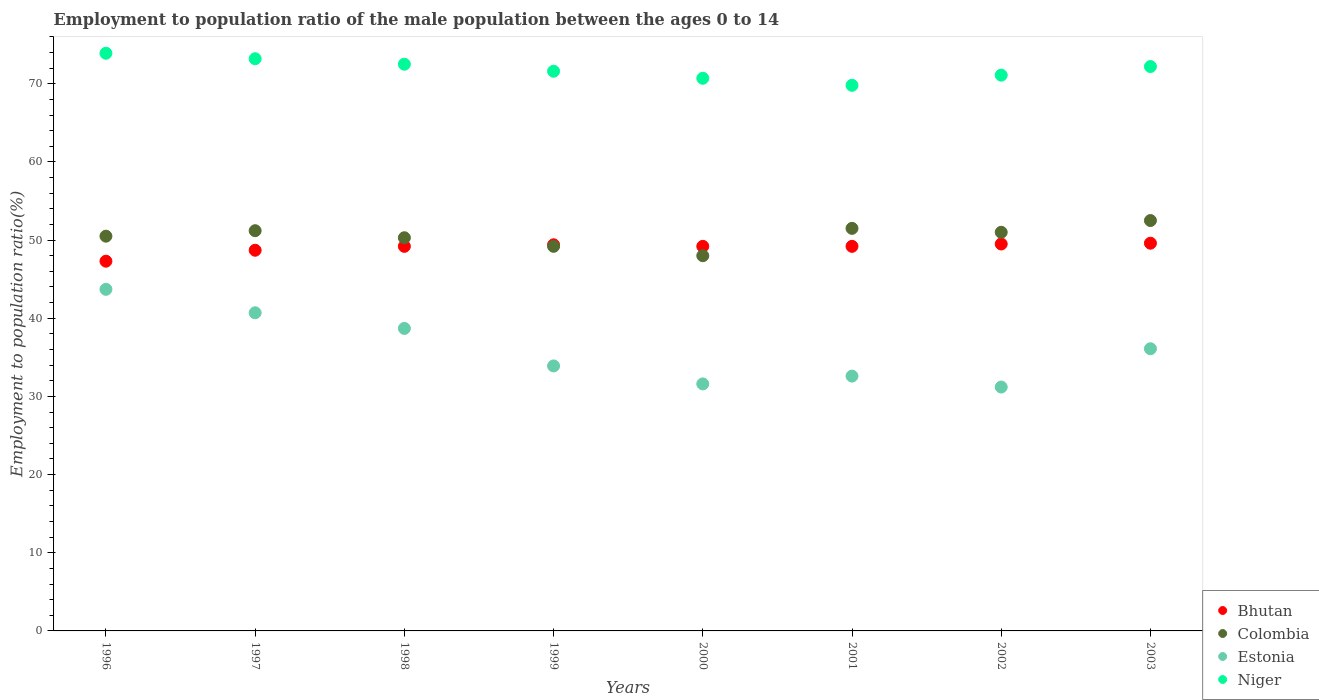Is the number of dotlines equal to the number of legend labels?
Make the answer very short. Yes. What is the employment to population ratio in Estonia in 2000?
Provide a short and direct response. 31.6. Across all years, what is the maximum employment to population ratio in Bhutan?
Provide a short and direct response. 49.6. Across all years, what is the minimum employment to population ratio in Bhutan?
Offer a terse response. 47.3. In which year was the employment to population ratio in Estonia maximum?
Provide a short and direct response. 1996. What is the total employment to population ratio in Niger in the graph?
Make the answer very short. 575. What is the difference between the employment to population ratio in Estonia in 1998 and that in 2000?
Your answer should be compact. 7.1. What is the difference between the employment to population ratio in Colombia in 2002 and the employment to population ratio in Estonia in 2000?
Your response must be concise. 19.4. What is the average employment to population ratio in Colombia per year?
Your answer should be very brief. 50.53. In the year 1996, what is the difference between the employment to population ratio in Colombia and employment to population ratio in Estonia?
Give a very brief answer. 6.8. What is the ratio of the employment to population ratio in Estonia in 1998 to that in 2001?
Give a very brief answer. 1.19. Is the difference between the employment to population ratio in Colombia in 1996 and 1999 greater than the difference between the employment to population ratio in Estonia in 1996 and 1999?
Your answer should be very brief. No. What is the difference between the highest and the second highest employment to population ratio in Bhutan?
Your answer should be very brief. 0.1. In how many years, is the employment to population ratio in Estonia greater than the average employment to population ratio in Estonia taken over all years?
Provide a short and direct response. 4. Does the employment to population ratio in Bhutan monotonically increase over the years?
Provide a succinct answer. No. Is the employment to population ratio in Niger strictly greater than the employment to population ratio in Bhutan over the years?
Offer a very short reply. Yes. Is the employment to population ratio in Niger strictly less than the employment to population ratio in Bhutan over the years?
Ensure brevity in your answer.  No. How many years are there in the graph?
Your answer should be compact. 8. Does the graph contain any zero values?
Your response must be concise. No. How many legend labels are there?
Ensure brevity in your answer.  4. How are the legend labels stacked?
Your answer should be very brief. Vertical. What is the title of the graph?
Offer a terse response. Employment to population ratio of the male population between the ages 0 to 14. What is the label or title of the X-axis?
Keep it short and to the point. Years. What is the Employment to population ratio(%) in Bhutan in 1996?
Offer a terse response. 47.3. What is the Employment to population ratio(%) in Colombia in 1996?
Your response must be concise. 50.5. What is the Employment to population ratio(%) of Estonia in 1996?
Give a very brief answer. 43.7. What is the Employment to population ratio(%) of Niger in 1996?
Make the answer very short. 73.9. What is the Employment to population ratio(%) in Bhutan in 1997?
Your answer should be very brief. 48.7. What is the Employment to population ratio(%) of Colombia in 1997?
Your answer should be compact. 51.2. What is the Employment to population ratio(%) of Estonia in 1997?
Give a very brief answer. 40.7. What is the Employment to population ratio(%) in Niger in 1997?
Your response must be concise. 73.2. What is the Employment to population ratio(%) of Bhutan in 1998?
Make the answer very short. 49.2. What is the Employment to population ratio(%) of Colombia in 1998?
Ensure brevity in your answer.  50.3. What is the Employment to population ratio(%) in Estonia in 1998?
Give a very brief answer. 38.7. What is the Employment to population ratio(%) in Niger in 1998?
Your answer should be very brief. 72.5. What is the Employment to population ratio(%) of Bhutan in 1999?
Keep it short and to the point. 49.4. What is the Employment to population ratio(%) of Colombia in 1999?
Your answer should be very brief. 49.2. What is the Employment to population ratio(%) in Estonia in 1999?
Offer a very short reply. 33.9. What is the Employment to population ratio(%) in Niger in 1999?
Make the answer very short. 71.6. What is the Employment to population ratio(%) of Bhutan in 2000?
Provide a succinct answer. 49.2. What is the Employment to population ratio(%) of Colombia in 2000?
Provide a succinct answer. 48. What is the Employment to population ratio(%) in Estonia in 2000?
Keep it short and to the point. 31.6. What is the Employment to population ratio(%) in Niger in 2000?
Make the answer very short. 70.7. What is the Employment to population ratio(%) of Bhutan in 2001?
Your response must be concise. 49.2. What is the Employment to population ratio(%) in Colombia in 2001?
Your answer should be compact. 51.5. What is the Employment to population ratio(%) of Estonia in 2001?
Your answer should be compact. 32.6. What is the Employment to population ratio(%) in Niger in 2001?
Offer a terse response. 69.8. What is the Employment to population ratio(%) in Bhutan in 2002?
Offer a terse response. 49.5. What is the Employment to population ratio(%) of Colombia in 2002?
Offer a terse response. 51. What is the Employment to population ratio(%) in Estonia in 2002?
Give a very brief answer. 31.2. What is the Employment to population ratio(%) of Niger in 2002?
Your answer should be very brief. 71.1. What is the Employment to population ratio(%) of Bhutan in 2003?
Your response must be concise. 49.6. What is the Employment to population ratio(%) of Colombia in 2003?
Give a very brief answer. 52.5. What is the Employment to population ratio(%) of Estonia in 2003?
Provide a succinct answer. 36.1. What is the Employment to population ratio(%) of Niger in 2003?
Offer a terse response. 72.2. Across all years, what is the maximum Employment to population ratio(%) in Bhutan?
Your response must be concise. 49.6. Across all years, what is the maximum Employment to population ratio(%) of Colombia?
Offer a terse response. 52.5. Across all years, what is the maximum Employment to population ratio(%) of Estonia?
Give a very brief answer. 43.7. Across all years, what is the maximum Employment to population ratio(%) in Niger?
Your response must be concise. 73.9. Across all years, what is the minimum Employment to population ratio(%) in Bhutan?
Provide a short and direct response. 47.3. Across all years, what is the minimum Employment to population ratio(%) in Colombia?
Offer a terse response. 48. Across all years, what is the minimum Employment to population ratio(%) in Estonia?
Give a very brief answer. 31.2. Across all years, what is the minimum Employment to population ratio(%) in Niger?
Provide a short and direct response. 69.8. What is the total Employment to population ratio(%) of Bhutan in the graph?
Offer a terse response. 392.1. What is the total Employment to population ratio(%) of Colombia in the graph?
Keep it short and to the point. 404.2. What is the total Employment to population ratio(%) of Estonia in the graph?
Offer a terse response. 288.5. What is the total Employment to population ratio(%) in Niger in the graph?
Your response must be concise. 575. What is the difference between the Employment to population ratio(%) in Bhutan in 1996 and that in 1997?
Your response must be concise. -1.4. What is the difference between the Employment to population ratio(%) in Bhutan in 1996 and that in 1998?
Keep it short and to the point. -1.9. What is the difference between the Employment to population ratio(%) of Colombia in 1996 and that in 1998?
Your answer should be compact. 0.2. What is the difference between the Employment to population ratio(%) of Estonia in 1996 and that in 1998?
Provide a succinct answer. 5. What is the difference between the Employment to population ratio(%) of Niger in 1996 and that in 1998?
Provide a short and direct response. 1.4. What is the difference between the Employment to population ratio(%) in Estonia in 1996 and that in 1999?
Your response must be concise. 9.8. What is the difference between the Employment to population ratio(%) in Bhutan in 1996 and that in 2000?
Provide a short and direct response. -1.9. What is the difference between the Employment to population ratio(%) in Colombia in 1996 and that in 2000?
Your answer should be very brief. 2.5. What is the difference between the Employment to population ratio(%) in Colombia in 1996 and that in 2001?
Offer a very short reply. -1. What is the difference between the Employment to population ratio(%) of Estonia in 1996 and that in 2001?
Ensure brevity in your answer.  11.1. What is the difference between the Employment to population ratio(%) in Colombia in 1996 and that in 2003?
Provide a short and direct response. -2. What is the difference between the Employment to population ratio(%) of Bhutan in 1997 and that in 1998?
Offer a very short reply. -0.5. What is the difference between the Employment to population ratio(%) of Colombia in 1997 and that in 1998?
Offer a terse response. 0.9. What is the difference between the Employment to population ratio(%) of Colombia in 1997 and that in 1999?
Keep it short and to the point. 2. What is the difference between the Employment to population ratio(%) in Colombia in 1997 and that in 2000?
Your response must be concise. 3.2. What is the difference between the Employment to population ratio(%) of Estonia in 1997 and that in 2000?
Ensure brevity in your answer.  9.1. What is the difference between the Employment to population ratio(%) in Niger in 1997 and that in 2000?
Provide a succinct answer. 2.5. What is the difference between the Employment to population ratio(%) in Colombia in 1997 and that in 2001?
Ensure brevity in your answer.  -0.3. What is the difference between the Employment to population ratio(%) of Estonia in 1997 and that in 2001?
Your answer should be compact. 8.1. What is the difference between the Employment to population ratio(%) in Niger in 1997 and that in 2001?
Offer a terse response. 3.4. What is the difference between the Employment to population ratio(%) in Estonia in 1997 and that in 2002?
Provide a short and direct response. 9.5. What is the difference between the Employment to population ratio(%) of Estonia in 1997 and that in 2003?
Your answer should be very brief. 4.6. What is the difference between the Employment to population ratio(%) of Niger in 1997 and that in 2003?
Your response must be concise. 1. What is the difference between the Employment to population ratio(%) in Colombia in 1998 and that in 1999?
Keep it short and to the point. 1.1. What is the difference between the Employment to population ratio(%) in Estonia in 1998 and that in 2000?
Provide a short and direct response. 7.1. What is the difference between the Employment to population ratio(%) of Estonia in 1998 and that in 2001?
Give a very brief answer. 6.1. What is the difference between the Employment to population ratio(%) of Colombia in 1998 and that in 2002?
Ensure brevity in your answer.  -0.7. What is the difference between the Employment to population ratio(%) in Estonia in 1998 and that in 2002?
Give a very brief answer. 7.5. What is the difference between the Employment to population ratio(%) of Niger in 1998 and that in 2002?
Your answer should be very brief. 1.4. What is the difference between the Employment to population ratio(%) in Bhutan in 1998 and that in 2003?
Keep it short and to the point. -0.4. What is the difference between the Employment to population ratio(%) of Estonia in 1998 and that in 2003?
Your response must be concise. 2.6. What is the difference between the Employment to population ratio(%) in Niger in 1998 and that in 2003?
Give a very brief answer. 0.3. What is the difference between the Employment to population ratio(%) of Colombia in 1999 and that in 2000?
Offer a very short reply. 1.2. What is the difference between the Employment to population ratio(%) of Estonia in 1999 and that in 2000?
Give a very brief answer. 2.3. What is the difference between the Employment to population ratio(%) of Colombia in 1999 and that in 2001?
Provide a short and direct response. -2.3. What is the difference between the Employment to population ratio(%) of Colombia in 1999 and that in 2002?
Your response must be concise. -1.8. What is the difference between the Employment to population ratio(%) in Estonia in 1999 and that in 2002?
Give a very brief answer. 2.7. What is the difference between the Employment to population ratio(%) in Niger in 1999 and that in 2002?
Offer a very short reply. 0.5. What is the difference between the Employment to population ratio(%) in Colombia in 2000 and that in 2001?
Your answer should be very brief. -3.5. What is the difference between the Employment to population ratio(%) of Bhutan in 2000 and that in 2002?
Ensure brevity in your answer.  -0.3. What is the difference between the Employment to population ratio(%) of Niger in 2000 and that in 2002?
Provide a short and direct response. -0.4. What is the difference between the Employment to population ratio(%) of Bhutan in 2000 and that in 2003?
Provide a short and direct response. -0.4. What is the difference between the Employment to population ratio(%) in Estonia in 2000 and that in 2003?
Your response must be concise. -4.5. What is the difference between the Employment to population ratio(%) in Estonia in 2001 and that in 2002?
Your response must be concise. 1.4. What is the difference between the Employment to population ratio(%) of Niger in 2001 and that in 2002?
Your response must be concise. -1.3. What is the difference between the Employment to population ratio(%) in Colombia in 2001 and that in 2003?
Offer a very short reply. -1. What is the difference between the Employment to population ratio(%) in Niger in 2001 and that in 2003?
Ensure brevity in your answer.  -2.4. What is the difference between the Employment to population ratio(%) of Bhutan in 2002 and that in 2003?
Your answer should be very brief. -0.1. What is the difference between the Employment to population ratio(%) of Estonia in 2002 and that in 2003?
Keep it short and to the point. -4.9. What is the difference between the Employment to population ratio(%) of Bhutan in 1996 and the Employment to population ratio(%) of Niger in 1997?
Provide a short and direct response. -25.9. What is the difference between the Employment to population ratio(%) in Colombia in 1996 and the Employment to population ratio(%) in Estonia in 1997?
Ensure brevity in your answer.  9.8. What is the difference between the Employment to population ratio(%) of Colombia in 1996 and the Employment to population ratio(%) of Niger in 1997?
Your response must be concise. -22.7. What is the difference between the Employment to population ratio(%) in Estonia in 1996 and the Employment to population ratio(%) in Niger in 1997?
Provide a short and direct response. -29.5. What is the difference between the Employment to population ratio(%) in Bhutan in 1996 and the Employment to population ratio(%) in Colombia in 1998?
Give a very brief answer. -3. What is the difference between the Employment to population ratio(%) of Bhutan in 1996 and the Employment to population ratio(%) of Niger in 1998?
Keep it short and to the point. -25.2. What is the difference between the Employment to population ratio(%) in Estonia in 1996 and the Employment to population ratio(%) in Niger in 1998?
Your response must be concise. -28.8. What is the difference between the Employment to population ratio(%) in Bhutan in 1996 and the Employment to population ratio(%) in Colombia in 1999?
Give a very brief answer. -1.9. What is the difference between the Employment to population ratio(%) of Bhutan in 1996 and the Employment to population ratio(%) of Niger in 1999?
Make the answer very short. -24.3. What is the difference between the Employment to population ratio(%) of Colombia in 1996 and the Employment to population ratio(%) of Estonia in 1999?
Your answer should be compact. 16.6. What is the difference between the Employment to population ratio(%) in Colombia in 1996 and the Employment to population ratio(%) in Niger in 1999?
Give a very brief answer. -21.1. What is the difference between the Employment to population ratio(%) of Estonia in 1996 and the Employment to population ratio(%) of Niger in 1999?
Offer a terse response. -27.9. What is the difference between the Employment to population ratio(%) of Bhutan in 1996 and the Employment to population ratio(%) of Colombia in 2000?
Make the answer very short. -0.7. What is the difference between the Employment to population ratio(%) in Bhutan in 1996 and the Employment to population ratio(%) in Niger in 2000?
Provide a short and direct response. -23.4. What is the difference between the Employment to population ratio(%) of Colombia in 1996 and the Employment to population ratio(%) of Niger in 2000?
Offer a very short reply. -20.2. What is the difference between the Employment to population ratio(%) of Estonia in 1996 and the Employment to population ratio(%) of Niger in 2000?
Offer a terse response. -27. What is the difference between the Employment to population ratio(%) of Bhutan in 1996 and the Employment to population ratio(%) of Colombia in 2001?
Provide a succinct answer. -4.2. What is the difference between the Employment to population ratio(%) in Bhutan in 1996 and the Employment to population ratio(%) in Estonia in 2001?
Offer a terse response. 14.7. What is the difference between the Employment to population ratio(%) in Bhutan in 1996 and the Employment to population ratio(%) in Niger in 2001?
Provide a short and direct response. -22.5. What is the difference between the Employment to population ratio(%) of Colombia in 1996 and the Employment to population ratio(%) of Niger in 2001?
Offer a terse response. -19.3. What is the difference between the Employment to population ratio(%) of Estonia in 1996 and the Employment to population ratio(%) of Niger in 2001?
Offer a terse response. -26.1. What is the difference between the Employment to population ratio(%) in Bhutan in 1996 and the Employment to population ratio(%) in Estonia in 2002?
Offer a terse response. 16.1. What is the difference between the Employment to population ratio(%) of Bhutan in 1996 and the Employment to population ratio(%) of Niger in 2002?
Your answer should be compact. -23.8. What is the difference between the Employment to population ratio(%) in Colombia in 1996 and the Employment to population ratio(%) in Estonia in 2002?
Your answer should be very brief. 19.3. What is the difference between the Employment to population ratio(%) in Colombia in 1996 and the Employment to population ratio(%) in Niger in 2002?
Provide a succinct answer. -20.6. What is the difference between the Employment to population ratio(%) of Estonia in 1996 and the Employment to population ratio(%) of Niger in 2002?
Make the answer very short. -27.4. What is the difference between the Employment to population ratio(%) of Bhutan in 1996 and the Employment to population ratio(%) of Colombia in 2003?
Your answer should be very brief. -5.2. What is the difference between the Employment to population ratio(%) in Bhutan in 1996 and the Employment to population ratio(%) in Estonia in 2003?
Your answer should be compact. 11.2. What is the difference between the Employment to population ratio(%) of Bhutan in 1996 and the Employment to population ratio(%) of Niger in 2003?
Your answer should be compact. -24.9. What is the difference between the Employment to population ratio(%) of Colombia in 1996 and the Employment to population ratio(%) of Estonia in 2003?
Your answer should be compact. 14.4. What is the difference between the Employment to population ratio(%) in Colombia in 1996 and the Employment to population ratio(%) in Niger in 2003?
Provide a succinct answer. -21.7. What is the difference between the Employment to population ratio(%) of Estonia in 1996 and the Employment to population ratio(%) of Niger in 2003?
Ensure brevity in your answer.  -28.5. What is the difference between the Employment to population ratio(%) of Bhutan in 1997 and the Employment to population ratio(%) of Colombia in 1998?
Give a very brief answer. -1.6. What is the difference between the Employment to population ratio(%) of Bhutan in 1997 and the Employment to population ratio(%) of Estonia in 1998?
Your answer should be very brief. 10. What is the difference between the Employment to population ratio(%) in Bhutan in 1997 and the Employment to population ratio(%) in Niger in 1998?
Offer a very short reply. -23.8. What is the difference between the Employment to population ratio(%) in Colombia in 1997 and the Employment to population ratio(%) in Estonia in 1998?
Give a very brief answer. 12.5. What is the difference between the Employment to population ratio(%) of Colombia in 1997 and the Employment to population ratio(%) of Niger in 1998?
Your response must be concise. -21.3. What is the difference between the Employment to population ratio(%) of Estonia in 1997 and the Employment to population ratio(%) of Niger in 1998?
Give a very brief answer. -31.8. What is the difference between the Employment to population ratio(%) of Bhutan in 1997 and the Employment to population ratio(%) of Niger in 1999?
Provide a succinct answer. -22.9. What is the difference between the Employment to population ratio(%) of Colombia in 1997 and the Employment to population ratio(%) of Niger in 1999?
Offer a terse response. -20.4. What is the difference between the Employment to population ratio(%) of Estonia in 1997 and the Employment to population ratio(%) of Niger in 1999?
Ensure brevity in your answer.  -30.9. What is the difference between the Employment to population ratio(%) of Bhutan in 1997 and the Employment to population ratio(%) of Estonia in 2000?
Provide a short and direct response. 17.1. What is the difference between the Employment to population ratio(%) of Bhutan in 1997 and the Employment to population ratio(%) of Niger in 2000?
Make the answer very short. -22. What is the difference between the Employment to population ratio(%) of Colombia in 1997 and the Employment to population ratio(%) of Estonia in 2000?
Offer a terse response. 19.6. What is the difference between the Employment to population ratio(%) of Colombia in 1997 and the Employment to population ratio(%) of Niger in 2000?
Your answer should be very brief. -19.5. What is the difference between the Employment to population ratio(%) in Estonia in 1997 and the Employment to population ratio(%) in Niger in 2000?
Offer a very short reply. -30. What is the difference between the Employment to population ratio(%) of Bhutan in 1997 and the Employment to population ratio(%) of Colombia in 2001?
Provide a succinct answer. -2.8. What is the difference between the Employment to population ratio(%) of Bhutan in 1997 and the Employment to population ratio(%) of Niger in 2001?
Your answer should be very brief. -21.1. What is the difference between the Employment to population ratio(%) of Colombia in 1997 and the Employment to population ratio(%) of Estonia in 2001?
Keep it short and to the point. 18.6. What is the difference between the Employment to population ratio(%) in Colombia in 1997 and the Employment to population ratio(%) in Niger in 2001?
Give a very brief answer. -18.6. What is the difference between the Employment to population ratio(%) in Estonia in 1997 and the Employment to population ratio(%) in Niger in 2001?
Offer a very short reply. -29.1. What is the difference between the Employment to population ratio(%) in Bhutan in 1997 and the Employment to population ratio(%) in Colombia in 2002?
Your response must be concise. -2.3. What is the difference between the Employment to population ratio(%) in Bhutan in 1997 and the Employment to population ratio(%) in Niger in 2002?
Ensure brevity in your answer.  -22.4. What is the difference between the Employment to population ratio(%) in Colombia in 1997 and the Employment to population ratio(%) in Estonia in 2002?
Your response must be concise. 20. What is the difference between the Employment to population ratio(%) of Colombia in 1997 and the Employment to population ratio(%) of Niger in 2002?
Offer a terse response. -19.9. What is the difference between the Employment to population ratio(%) of Estonia in 1997 and the Employment to population ratio(%) of Niger in 2002?
Make the answer very short. -30.4. What is the difference between the Employment to population ratio(%) in Bhutan in 1997 and the Employment to population ratio(%) in Colombia in 2003?
Your answer should be very brief. -3.8. What is the difference between the Employment to population ratio(%) of Bhutan in 1997 and the Employment to population ratio(%) of Niger in 2003?
Provide a succinct answer. -23.5. What is the difference between the Employment to population ratio(%) in Colombia in 1997 and the Employment to population ratio(%) in Estonia in 2003?
Keep it short and to the point. 15.1. What is the difference between the Employment to population ratio(%) of Estonia in 1997 and the Employment to population ratio(%) of Niger in 2003?
Give a very brief answer. -31.5. What is the difference between the Employment to population ratio(%) of Bhutan in 1998 and the Employment to population ratio(%) of Niger in 1999?
Provide a short and direct response. -22.4. What is the difference between the Employment to population ratio(%) of Colombia in 1998 and the Employment to population ratio(%) of Niger in 1999?
Your answer should be very brief. -21.3. What is the difference between the Employment to population ratio(%) of Estonia in 1998 and the Employment to population ratio(%) of Niger in 1999?
Your answer should be very brief. -32.9. What is the difference between the Employment to population ratio(%) of Bhutan in 1998 and the Employment to population ratio(%) of Colombia in 2000?
Offer a very short reply. 1.2. What is the difference between the Employment to population ratio(%) in Bhutan in 1998 and the Employment to population ratio(%) in Niger in 2000?
Offer a very short reply. -21.5. What is the difference between the Employment to population ratio(%) of Colombia in 1998 and the Employment to population ratio(%) of Estonia in 2000?
Provide a succinct answer. 18.7. What is the difference between the Employment to population ratio(%) in Colombia in 1998 and the Employment to population ratio(%) in Niger in 2000?
Make the answer very short. -20.4. What is the difference between the Employment to population ratio(%) in Estonia in 1998 and the Employment to population ratio(%) in Niger in 2000?
Keep it short and to the point. -32. What is the difference between the Employment to population ratio(%) of Bhutan in 1998 and the Employment to population ratio(%) of Colombia in 2001?
Give a very brief answer. -2.3. What is the difference between the Employment to population ratio(%) of Bhutan in 1998 and the Employment to population ratio(%) of Niger in 2001?
Offer a very short reply. -20.6. What is the difference between the Employment to population ratio(%) in Colombia in 1998 and the Employment to population ratio(%) in Estonia in 2001?
Provide a short and direct response. 17.7. What is the difference between the Employment to population ratio(%) in Colombia in 1998 and the Employment to population ratio(%) in Niger in 2001?
Offer a terse response. -19.5. What is the difference between the Employment to population ratio(%) of Estonia in 1998 and the Employment to population ratio(%) of Niger in 2001?
Your answer should be compact. -31.1. What is the difference between the Employment to population ratio(%) of Bhutan in 1998 and the Employment to population ratio(%) of Colombia in 2002?
Your answer should be compact. -1.8. What is the difference between the Employment to population ratio(%) in Bhutan in 1998 and the Employment to population ratio(%) in Estonia in 2002?
Your response must be concise. 18. What is the difference between the Employment to population ratio(%) in Bhutan in 1998 and the Employment to population ratio(%) in Niger in 2002?
Your answer should be compact. -21.9. What is the difference between the Employment to population ratio(%) of Colombia in 1998 and the Employment to population ratio(%) of Estonia in 2002?
Offer a terse response. 19.1. What is the difference between the Employment to population ratio(%) in Colombia in 1998 and the Employment to population ratio(%) in Niger in 2002?
Keep it short and to the point. -20.8. What is the difference between the Employment to population ratio(%) of Estonia in 1998 and the Employment to population ratio(%) of Niger in 2002?
Offer a terse response. -32.4. What is the difference between the Employment to population ratio(%) of Colombia in 1998 and the Employment to population ratio(%) of Niger in 2003?
Ensure brevity in your answer.  -21.9. What is the difference between the Employment to population ratio(%) in Estonia in 1998 and the Employment to population ratio(%) in Niger in 2003?
Make the answer very short. -33.5. What is the difference between the Employment to population ratio(%) in Bhutan in 1999 and the Employment to population ratio(%) in Colombia in 2000?
Keep it short and to the point. 1.4. What is the difference between the Employment to population ratio(%) of Bhutan in 1999 and the Employment to population ratio(%) of Niger in 2000?
Keep it short and to the point. -21.3. What is the difference between the Employment to population ratio(%) of Colombia in 1999 and the Employment to population ratio(%) of Estonia in 2000?
Offer a terse response. 17.6. What is the difference between the Employment to population ratio(%) in Colombia in 1999 and the Employment to population ratio(%) in Niger in 2000?
Offer a very short reply. -21.5. What is the difference between the Employment to population ratio(%) in Estonia in 1999 and the Employment to population ratio(%) in Niger in 2000?
Give a very brief answer. -36.8. What is the difference between the Employment to population ratio(%) in Bhutan in 1999 and the Employment to population ratio(%) in Niger in 2001?
Offer a very short reply. -20.4. What is the difference between the Employment to population ratio(%) of Colombia in 1999 and the Employment to population ratio(%) of Niger in 2001?
Your answer should be compact. -20.6. What is the difference between the Employment to population ratio(%) in Estonia in 1999 and the Employment to population ratio(%) in Niger in 2001?
Your response must be concise. -35.9. What is the difference between the Employment to population ratio(%) in Bhutan in 1999 and the Employment to population ratio(%) in Niger in 2002?
Your answer should be compact. -21.7. What is the difference between the Employment to population ratio(%) in Colombia in 1999 and the Employment to population ratio(%) in Estonia in 2002?
Your response must be concise. 18. What is the difference between the Employment to population ratio(%) of Colombia in 1999 and the Employment to population ratio(%) of Niger in 2002?
Provide a short and direct response. -21.9. What is the difference between the Employment to population ratio(%) of Estonia in 1999 and the Employment to population ratio(%) of Niger in 2002?
Ensure brevity in your answer.  -37.2. What is the difference between the Employment to population ratio(%) in Bhutan in 1999 and the Employment to population ratio(%) in Colombia in 2003?
Provide a succinct answer. -3.1. What is the difference between the Employment to population ratio(%) in Bhutan in 1999 and the Employment to population ratio(%) in Niger in 2003?
Provide a short and direct response. -22.8. What is the difference between the Employment to population ratio(%) of Estonia in 1999 and the Employment to population ratio(%) of Niger in 2003?
Keep it short and to the point. -38.3. What is the difference between the Employment to population ratio(%) in Bhutan in 2000 and the Employment to population ratio(%) in Estonia in 2001?
Keep it short and to the point. 16.6. What is the difference between the Employment to population ratio(%) of Bhutan in 2000 and the Employment to population ratio(%) of Niger in 2001?
Offer a very short reply. -20.6. What is the difference between the Employment to population ratio(%) in Colombia in 2000 and the Employment to population ratio(%) in Estonia in 2001?
Give a very brief answer. 15.4. What is the difference between the Employment to population ratio(%) of Colombia in 2000 and the Employment to population ratio(%) of Niger in 2001?
Offer a very short reply. -21.8. What is the difference between the Employment to population ratio(%) in Estonia in 2000 and the Employment to population ratio(%) in Niger in 2001?
Provide a short and direct response. -38.2. What is the difference between the Employment to population ratio(%) in Bhutan in 2000 and the Employment to population ratio(%) in Niger in 2002?
Your answer should be compact. -21.9. What is the difference between the Employment to population ratio(%) in Colombia in 2000 and the Employment to population ratio(%) in Niger in 2002?
Your answer should be compact. -23.1. What is the difference between the Employment to population ratio(%) in Estonia in 2000 and the Employment to population ratio(%) in Niger in 2002?
Give a very brief answer. -39.5. What is the difference between the Employment to population ratio(%) in Bhutan in 2000 and the Employment to population ratio(%) in Estonia in 2003?
Offer a terse response. 13.1. What is the difference between the Employment to population ratio(%) of Bhutan in 2000 and the Employment to population ratio(%) of Niger in 2003?
Ensure brevity in your answer.  -23. What is the difference between the Employment to population ratio(%) in Colombia in 2000 and the Employment to population ratio(%) in Niger in 2003?
Ensure brevity in your answer.  -24.2. What is the difference between the Employment to population ratio(%) in Estonia in 2000 and the Employment to population ratio(%) in Niger in 2003?
Ensure brevity in your answer.  -40.6. What is the difference between the Employment to population ratio(%) in Bhutan in 2001 and the Employment to population ratio(%) in Colombia in 2002?
Provide a short and direct response. -1.8. What is the difference between the Employment to population ratio(%) of Bhutan in 2001 and the Employment to population ratio(%) of Niger in 2002?
Keep it short and to the point. -21.9. What is the difference between the Employment to population ratio(%) in Colombia in 2001 and the Employment to population ratio(%) in Estonia in 2002?
Your answer should be compact. 20.3. What is the difference between the Employment to population ratio(%) of Colombia in 2001 and the Employment to population ratio(%) of Niger in 2002?
Your response must be concise. -19.6. What is the difference between the Employment to population ratio(%) of Estonia in 2001 and the Employment to population ratio(%) of Niger in 2002?
Provide a short and direct response. -38.5. What is the difference between the Employment to population ratio(%) of Bhutan in 2001 and the Employment to population ratio(%) of Estonia in 2003?
Give a very brief answer. 13.1. What is the difference between the Employment to population ratio(%) in Colombia in 2001 and the Employment to population ratio(%) in Estonia in 2003?
Keep it short and to the point. 15.4. What is the difference between the Employment to population ratio(%) in Colombia in 2001 and the Employment to population ratio(%) in Niger in 2003?
Offer a terse response. -20.7. What is the difference between the Employment to population ratio(%) in Estonia in 2001 and the Employment to population ratio(%) in Niger in 2003?
Provide a succinct answer. -39.6. What is the difference between the Employment to population ratio(%) in Bhutan in 2002 and the Employment to population ratio(%) in Niger in 2003?
Keep it short and to the point. -22.7. What is the difference between the Employment to population ratio(%) in Colombia in 2002 and the Employment to population ratio(%) in Niger in 2003?
Your answer should be very brief. -21.2. What is the difference between the Employment to population ratio(%) in Estonia in 2002 and the Employment to population ratio(%) in Niger in 2003?
Provide a short and direct response. -41. What is the average Employment to population ratio(%) of Bhutan per year?
Give a very brief answer. 49.01. What is the average Employment to population ratio(%) of Colombia per year?
Provide a short and direct response. 50.52. What is the average Employment to population ratio(%) in Estonia per year?
Offer a terse response. 36.06. What is the average Employment to population ratio(%) of Niger per year?
Your answer should be very brief. 71.88. In the year 1996, what is the difference between the Employment to population ratio(%) in Bhutan and Employment to population ratio(%) in Colombia?
Your answer should be very brief. -3.2. In the year 1996, what is the difference between the Employment to population ratio(%) in Bhutan and Employment to population ratio(%) in Estonia?
Give a very brief answer. 3.6. In the year 1996, what is the difference between the Employment to population ratio(%) of Bhutan and Employment to population ratio(%) of Niger?
Your answer should be very brief. -26.6. In the year 1996, what is the difference between the Employment to population ratio(%) of Colombia and Employment to population ratio(%) of Estonia?
Your response must be concise. 6.8. In the year 1996, what is the difference between the Employment to population ratio(%) in Colombia and Employment to population ratio(%) in Niger?
Ensure brevity in your answer.  -23.4. In the year 1996, what is the difference between the Employment to population ratio(%) in Estonia and Employment to population ratio(%) in Niger?
Keep it short and to the point. -30.2. In the year 1997, what is the difference between the Employment to population ratio(%) of Bhutan and Employment to population ratio(%) of Colombia?
Your response must be concise. -2.5. In the year 1997, what is the difference between the Employment to population ratio(%) of Bhutan and Employment to population ratio(%) of Estonia?
Offer a very short reply. 8. In the year 1997, what is the difference between the Employment to population ratio(%) of Bhutan and Employment to population ratio(%) of Niger?
Your answer should be very brief. -24.5. In the year 1997, what is the difference between the Employment to population ratio(%) in Colombia and Employment to population ratio(%) in Estonia?
Give a very brief answer. 10.5. In the year 1997, what is the difference between the Employment to population ratio(%) in Colombia and Employment to population ratio(%) in Niger?
Provide a short and direct response. -22. In the year 1997, what is the difference between the Employment to population ratio(%) in Estonia and Employment to population ratio(%) in Niger?
Offer a terse response. -32.5. In the year 1998, what is the difference between the Employment to population ratio(%) of Bhutan and Employment to population ratio(%) of Colombia?
Give a very brief answer. -1.1. In the year 1998, what is the difference between the Employment to population ratio(%) of Bhutan and Employment to population ratio(%) of Niger?
Give a very brief answer. -23.3. In the year 1998, what is the difference between the Employment to population ratio(%) of Colombia and Employment to population ratio(%) of Niger?
Your answer should be very brief. -22.2. In the year 1998, what is the difference between the Employment to population ratio(%) in Estonia and Employment to population ratio(%) in Niger?
Provide a succinct answer. -33.8. In the year 1999, what is the difference between the Employment to population ratio(%) of Bhutan and Employment to population ratio(%) of Colombia?
Your response must be concise. 0.2. In the year 1999, what is the difference between the Employment to population ratio(%) in Bhutan and Employment to population ratio(%) in Estonia?
Your answer should be compact. 15.5. In the year 1999, what is the difference between the Employment to population ratio(%) of Bhutan and Employment to population ratio(%) of Niger?
Give a very brief answer. -22.2. In the year 1999, what is the difference between the Employment to population ratio(%) of Colombia and Employment to population ratio(%) of Estonia?
Ensure brevity in your answer.  15.3. In the year 1999, what is the difference between the Employment to population ratio(%) of Colombia and Employment to population ratio(%) of Niger?
Offer a very short reply. -22.4. In the year 1999, what is the difference between the Employment to population ratio(%) in Estonia and Employment to population ratio(%) in Niger?
Offer a very short reply. -37.7. In the year 2000, what is the difference between the Employment to population ratio(%) of Bhutan and Employment to population ratio(%) of Colombia?
Provide a short and direct response. 1.2. In the year 2000, what is the difference between the Employment to population ratio(%) of Bhutan and Employment to population ratio(%) of Niger?
Give a very brief answer. -21.5. In the year 2000, what is the difference between the Employment to population ratio(%) of Colombia and Employment to population ratio(%) of Niger?
Your answer should be compact. -22.7. In the year 2000, what is the difference between the Employment to population ratio(%) in Estonia and Employment to population ratio(%) in Niger?
Keep it short and to the point. -39.1. In the year 2001, what is the difference between the Employment to population ratio(%) of Bhutan and Employment to population ratio(%) of Niger?
Ensure brevity in your answer.  -20.6. In the year 2001, what is the difference between the Employment to population ratio(%) of Colombia and Employment to population ratio(%) of Estonia?
Offer a very short reply. 18.9. In the year 2001, what is the difference between the Employment to population ratio(%) of Colombia and Employment to population ratio(%) of Niger?
Keep it short and to the point. -18.3. In the year 2001, what is the difference between the Employment to population ratio(%) in Estonia and Employment to population ratio(%) in Niger?
Offer a terse response. -37.2. In the year 2002, what is the difference between the Employment to population ratio(%) of Bhutan and Employment to population ratio(%) of Colombia?
Offer a terse response. -1.5. In the year 2002, what is the difference between the Employment to population ratio(%) of Bhutan and Employment to population ratio(%) of Niger?
Provide a succinct answer. -21.6. In the year 2002, what is the difference between the Employment to population ratio(%) of Colombia and Employment to population ratio(%) of Estonia?
Provide a short and direct response. 19.8. In the year 2002, what is the difference between the Employment to population ratio(%) in Colombia and Employment to population ratio(%) in Niger?
Keep it short and to the point. -20.1. In the year 2002, what is the difference between the Employment to population ratio(%) of Estonia and Employment to population ratio(%) of Niger?
Provide a succinct answer. -39.9. In the year 2003, what is the difference between the Employment to population ratio(%) of Bhutan and Employment to population ratio(%) of Niger?
Your answer should be compact. -22.6. In the year 2003, what is the difference between the Employment to population ratio(%) in Colombia and Employment to population ratio(%) in Niger?
Your answer should be compact. -19.7. In the year 2003, what is the difference between the Employment to population ratio(%) in Estonia and Employment to population ratio(%) in Niger?
Provide a short and direct response. -36.1. What is the ratio of the Employment to population ratio(%) of Bhutan in 1996 to that in 1997?
Keep it short and to the point. 0.97. What is the ratio of the Employment to population ratio(%) of Colombia in 1996 to that in 1997?
Offer a terse response. 0.99. What is the ratio of the Employment to population ratio(%) in Estonia in 1996 to that in 1997?
Provide a succinct answer. 1.07. What is the ratio of the Employment to population ratio(%) in Niger in 1996 to that in 1997?
Offer a very short reply. 1.01. What is the ratio of the Employment to population ratio(%) of Bhutan in 1996 to that in 1998?
Keep it short and to the point. 0.96. What is the ratio of the Employment to population ratio(%) in Estonia in 1996 to that in 1998?
Your answer should be compact. 1.13. What is the ratio of the Employment to population ratio(%) of Niger in 1996 to that in 1998?
Your answer should be compact. 1.02. What is the ratio of the Employment to population ratio(%) of Bhutan in 1996 to that in 1999?
Your response must be concise. 0.96. What is the ratio of the Employment to population ratio(%) in Colombia in 1996 to that in 1999?
Your answer should be very brief. 1.03. What is the ratio of the Employment to population ratio(%) in Estonia in 1996 to that in 1999?
Your response must be concise. 1.29. What is the ratio of the Employment to population ratio(%) of Niger in 1996 to that in 1999?
Give a very brief answer. 1.03. What is the ratio of the Employment to population ratio(%) in Bhutan in 1996 to that in 2000?
Keep it short and to the point. 0.96. What is the ratio of the Employment to population ratio(%) in Colombia in 1996 to that in 2000?
Offer a very short reply. 1.05. What is the ratio of the Employment to population ratio(%) in Estonia in 1996 to that in 2000?
Provide a succinct answer. 1.38. What is the ratio of the Employment to population ratio(%) in Niger in 1996 to that in 2000?
Provide a short and direct response. 1.05. What is the ratio of the Employment to population ratio(%) in Bhutan in 1996 to that in 2001?
Ensure brevity in your answer.  0.96. What is the ratio of the Employment to population ratio(%) in Colombia in 1996 to that in 2001?
Your response must be concise. 0.98. What is the ratio of the Employment to population ratio(%) in Estonia in 1996 to that in 2001?
Your answer should be compact. 1.34. What is the ratio of the Employment to population ratio(%) of Niger in 1996 to that in 2001?
Keep it short and to the point. 1.06. What is the ratio of the Employment to population ratio(%) in Bhutan in 1996 to that in 2002?
Offer a very short reply. 0.96. What is the ratio of the Employment to population ratio(%) in Colombia in 1996 to that in 2002?
Give a very brief answer. 0.99. What is the ratio of the Employment to population ratio(%) in Estonia in 1996 to that in 2002?
Keep it short and to the point. 1.4. What is the ratio of the Employment to population ratio(%) in Niger in 1996 to that in 2002?
Your answer should be very brief. 1.04. What is the ratio of the Employment to population ratio(%) in Bhutan in 1996 to that in 2003?
Your answer should be very brief. 0.95. What is the ratio of the Employment to population ratio(%) in Colombia in 1996 to that in 2003?
Your answer should be very brief. 0.96. What is the ratio of the Employment to population ratio(%) in Estonia in 1996 to that in 2003?
Offer a terse response. 1.21. What is the ratio of the Employment to population ratio(%) of Niger in 1996 to that in 2003?
Ensure brevity in your answer.  1.02. What is the ratio of the Employment to population ratio(%) of Colombia in 1997 to that in 1998?
Provide a short and direct response. 1.02. What is the ratio of the Employment to population ratio(%) of Estonia in 1997 to that in 1998?
Your answer should be compact. 1.05. What is the ratio of the Employment to population ratio(%) in Niger in 1997 to that in 1998?
Provide a short and direct response. 1.01. What is the ratio of the Employment to population ratio(%) in Bhutan in 1997 to that in 1999?
Your answer should be very brief. 0.99. What is the ratio of the Employment to population ratio(%) of Colombia in 1997 to that in 1999?
Provide a short and direct response. 1.04. What is the ratio of the Employment to population ratio(%) in Estonia in 1997 to that in 1999?
Ensure brevity in your answer.  1.2. What is the ratio of the Employment to population ratio(%) of Niger in 1997 to that in 1999?
Make the answer very short. 1.02. What is the ratio of the Employment to population ratio(%) in Colombia in 1997 to that in 2000?
Offer a terse response. 1.07. What is the ratio of the Employment to population ratio(%) in Estonia in 1997 to that in 2000?
Your response must be concise. 1.29. What is the ratio of the Employment to population ratio(%) of Niger in 1997 to that in 2000?
Make the answer very short. 1.04. What is the ratio of the Employment to population ratio(%) in Estonia in 1997 to that in 2001?
Your answer should be very brief. 1.25. What is the ratio of the Employment to population ratio(%) of Niger in 1997 to that in 2001?
Your response must be concise. 1.05. What is the ratio of the Employment to population ratio(%) in Bhutan in 1997 to that in 2002?
Ensure brevity in your answer.  0.98. What is the ratio of the Employment to population ratio(%) of Colombia in 1997 to that in 2002?
Keep it short and to the point. 1. What is the ratio of the Employment to population ratio(%) of Estonia in 1997 to that in 2002?
Your answer should be very brief. 1.3. What is the ratio of the Employment to population ratio(%) of Niger in 1997 to that in 2002?
Provide a succinct answer. 1.03. What is the ratio of the Employment to population ratio(%) in Bhutan in 1997 to that in 2003?
Provide a succinct answer. 0.98. What is the ratio of the Employment to population ratio(%) in Colombia in 1997 to that in 2003?
Provide a short and direct response. 0.98. What is the ratio of the Employment to population ratio(%) in Estonia in 1997 to that in 2003?
Offer a terse response. 1.13. What is the ratio of the Employment to population ratio(%) of Niger in 1997 to that in 2003?
Keep it short and to the point. 1.01. What is the ratio of the Employment to population ratio(%) in Bhutan in 1998 to that in 1999?
Your answer should be compact. 1. What is the ratio of the Employment to population ratio(%) of Colombia in 1998 to that in 1999?
Make the answer very short. 1.02. What is the ratio of the Employment to population ratio(%) of Estonia in 1998 to that in 1999?
Make the answer very short. 1.14. What is the ratio of the Employment to population ratio(%) in Niger in 1998 to that in 1999?
Your answer should be compact. 1.01. What is the ratio of the Employment to population ratio(%) in Bhutan in 1998 to that in 2000?
Ensure brevity in your answer.  1. What is the ratio of the Employment to population ratio(%) of Colombia in 1998 to that in 2000?
Offer a terse response. 1.05. What is the ratio of the Employment to population ratio(%) in Estonia in 1998 to that in 2000?
Offer a very short reply. 1.22. What is the ratio of the Employment to population ratio(%) of Niger in 1998 to that in 2000?
Your answer should be compact. 1.03. What is the ratio of the Employment to population ratio(%) in Bhutan in 1998 to that in 2001?
Give a very brief answer. 1. What is the ratio of the Employment to population ratio(%) in Colombia in 1998 to that in 2001?
Give a very brief answer. 0.98. What is the ratio of the Employment to population ratio(%) in Estonia in 1998 to that in 2001?
Offer a very short reply. 1.19. What is the ratio of the Employment to population ratio(%) of Niger in 1998 to that in 2001?
Offer a terse response. 1.04. What is the ratio of the Employment to population ratio(%) of Colombia in 1998 to that in 2002?
Provide a short and direct response. 0.99. What is the ratio of the Employment to population ratio(%) of Estonia in 1998 to that in 2002?
Offer a terse response. 1.24. What is the ratio of the Employment to population ratio(%) of Niger in 1998 to that in 2002?
Keep it short and to the point. 1.02. What is the ratio of the Employment to population ratio(%) in Colombia in 1998 to that in 2003?
Provide a succinct answer. 0.96. What is the ratio of the Employment to population ratio(%) of Estonia in 1998 to that in 2003?
Your answer should be very brief. 1.07. What is the ratio of the Employment to population ratio(%) of Niger in 1998 to that in 2003?
Offer a terse response. 1. What is the ratio of the Employment to population ratio(%) of Bhutan in 1999 to that in 2000?
Your answer should be very brief. 1. What is the ratio of the Employment to population ratio(%) in Colombia in 1999 to that in 2000?
Offer a very short reply. 1.02. What is the ratio of the Employment to population ratio(%) in Estonia in 1999 to that in 2000?
Offer a terse response. 1.07. What is the ratio of the Employment to population ratio(%) of Niger in 1999 to that in 2000?
Make the answer very short. 1.01. What is the ratio of the Employment to population ratio(%) in Bhutan in 1999 to that in 2001?
Your response must be concise. 1. What is the ratio of the Employment to population ratio(%) of Colombia in 1999 to that in 2001?
Your answer should be very brief. 0.96. What is the ratio of the Employment to population ratio(%) of Estonia in 1999 to that in 2001?
Keep it short and to the point. 1.04. What is the ratio of the Employment to population ratio(%) of Niger in 1999 to that in 2001?
Provide a succinct answer. 1.03. What is the ratio of the Employment to population ratio(%) in Colombia in 1999 to that in 2002?
Provide a short and direct response. 0.96. What is the ratio of the Employment to population ratio(%) in Estonia in 1999 to that in 2002?
Ensure brevity in your answer.  1.09. What is the ratio of the Employment to population ratio(%) of Bhutan in 1999 to that in 2003?
Offer a terse response. 1. What is the ratio of the Employment to population ratio(%) in Colombia in 1999 to that in 2003?
Provide a succinct answer. 0.94. What is the ratio of the Employment to population ratio(%) of Estonia in 1999 to that in 2003?
Keep it short and to the point. 0.94. What is the ratio of the Employment to population ratio(%) in Niger in 1999 to that in 2003?
Your answer should be very brief. 0.99. What is the ratio of the Employment to population ratio(%) in Colombia in 2000 to that in 2001?
Give a very brief answer. 0.93. What is the ratio of the Employment to population ratio(%) of Estonia in 2000 to that in 2001?
Provide a short and direct response. 0.97. What is the ratio of the Employment to population ratio(%) of Niger in 2000 to that in 2001?
Ensure brevity in your answer.  1.01. What is the ratio of the Employment to population ratio(%) of Bhutan in 2000 to that in 2002?
Your answer should be compact. 0.99. What is the ratio of the Employment to population ratio(%) of Colombia in 2000 to that in 2002?
Your answer should be compact. 0.94. What is the ratio of the Employment to population ratio(%) in Estonia in 2000 to that in 2002?
Provide a short and direct response. 1.01. What is the ratio of the Employment to population ratio(%) in Niger in 2000 to that in 2002?
Give a very brief answer. 0.99. What is the ratio of the Employment to population ratio(%) of Colombia in 2000 to that in 2003?
Your response must be concise. 0.91. What is the ratio of the Employment to population ratio(%) in Estonia in 2000 to that in 2003?
Provide a succinct answer. 0.88. What is the ratio of the Employment to population ratio(%) in Niger in 2000 to that in 2003?
Offer a very short reply. 0.98. What is the ratio of the Employment to population ratio(%) of Colombia in 2001 to that in 2002?
Offer a very short reply. 1.01. What is the ratio of the Employment to population ratio(%) in Estonia in 2001 to that in 2002?
Your response must be concise. 1.04. What is the ratio of the Employment to population ratio(%) in Niger in 2001 to that in 2002?
Provide a succinct answer. 0.98. What is the ratio of the Employment to population ratio(%) of Bhutan in 2001 to that in 2003?
Provide a succinct answer. 0.99. What is the ratio of the Employment to population ratio(%) in Estonia in 2001 to that in 2003?
Offer a terse response. 0.9. What is the ratio of the Employment to population ratio(%) in Niger in 2001 to that in 2003?
Ensure brevity in your answer.  0.97. What is the ratio of the Employment to population ratio(%) in Colombia in 2002 to that in 2003?
Your answer should be compact. 0.97. What is the ratio of the Employment to population ratio(%) in Estonia in 2002 to that in 2003?
Provide a succinct answer. 0.86. What is the difference between the highest and the second highest Employment to population ratio(%) of Colombia?
Your answer should be compact. 1. What is the difference between the highest and the lowest Employment to population ratio(%) of Colombia?
Keep it short and to the point. 4.5. 